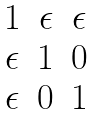Convert formula to latex. <formula><loc_0><loc_0><loc_500><loc_500>\begin{matrix} 1 & \epsilon & \epsilon \\ \epsilon & 1 & 0 \\ \epsilon & 0 & 1 \end{matrix}</formula> 